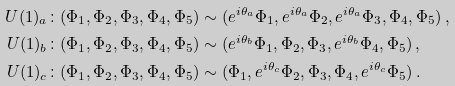Convert formula to latex. <formula><loc_0><loc_0><loc_500><loc_500>U ( 1 ) _ { a } & \colon ( \Phi _ { 1 } , \Phi _ { 2 } , \Phi _ { 3 } , \Phi _ { 4 } , \Phi _ { 5 } ) \sim ( e ^ { i \theta _ { a } } \Phi _ { 1 } , e ^ { i \theta _ { a } } \Phi _ { 2 } , e ^ { i \theta _ { a } } \Phi _ { 3 } , \Phi _ { 4 } , \Phi _ { 5 } ) \, , \\ U ( 1 ) _ { b } & \colon ( \Phi _ { 1 } , \Phi _ { 2 } , \Phi _ { 3 } , \Phi _ { 4 } , \Phi _ { 5 } ) \sim ( e ^ { i \theta _ { b } } \Phi _ { 1 } , \Phi _ { 2 } , \Phi _ { 3 } , e ^ { i \theta _ { b } } \Phi _ { 4 } , \Phi _ { 5 } ) \, , \\ U ( 1 ) _ { c } & \colon ( \Phi _ { 1 } , \Phi _ { 2 } , \Phi _ { 3 } , \Phi _ { 4 } , \Phi _ { 5 } ) \sim ( \Phi _ { 1 } , e ^ { i \theta _ { c } } \Phi _ { 2 } , \Phi _ { 3 } , \Phi _ { 4 } , e ^ { i \theta _ { c } } \Phi _ { 5 } ) \, .</formula> 